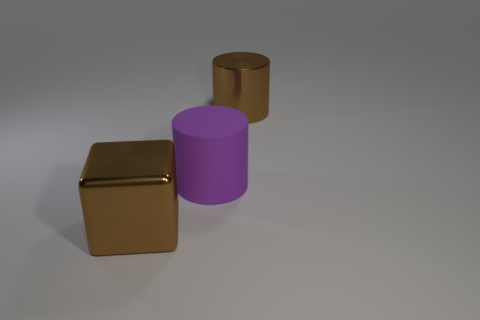Add 2 small yellow cubes. How many objects exist? 5 Subtract all cylinders. How many objects are left? 1 Add 2 large rubber cylinders. How many large rubber cylinders are left? 3 Add 1 blocks. How many blocks exist? 2 Subtract 0 gray cylinders. How many objects are left? 3 Subtract all cyan metal cubes. Subtract all large rubber objects. How many objects are left? 2 